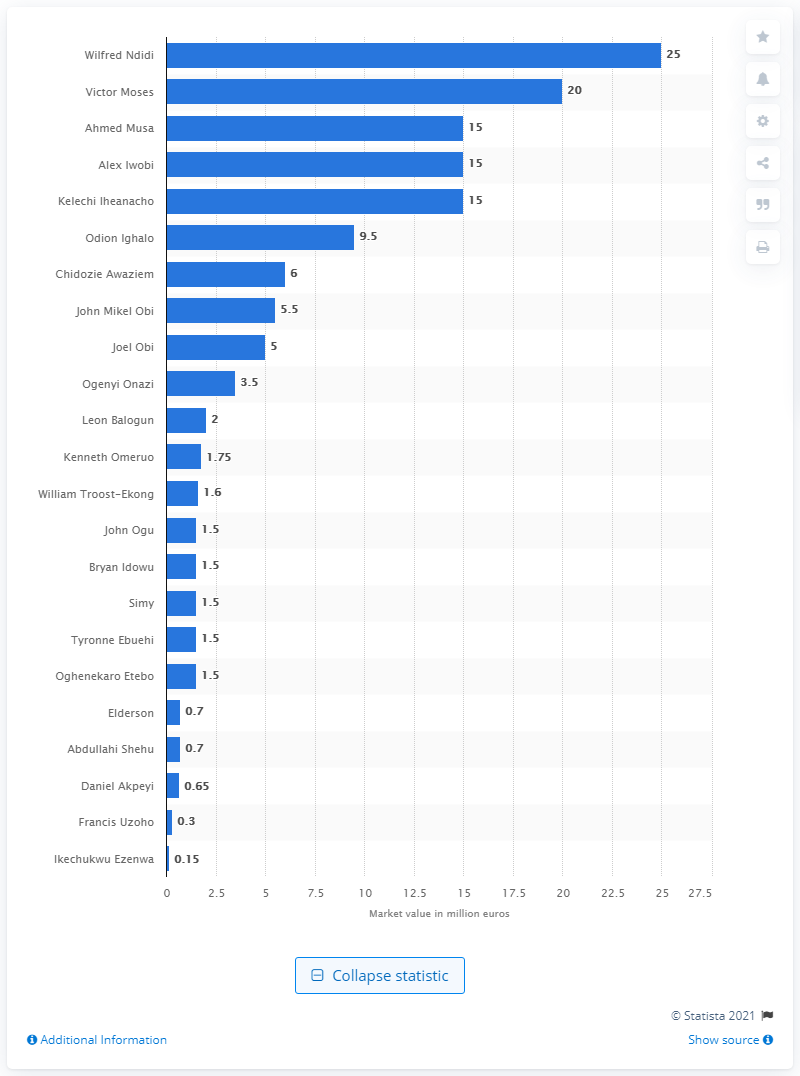List a handful of essential elements in this visual. The market value of Ndidi was 25.. Nigeria's most valuable player at the 2018 FIFA World Cup was Wilfred Ndidi. 